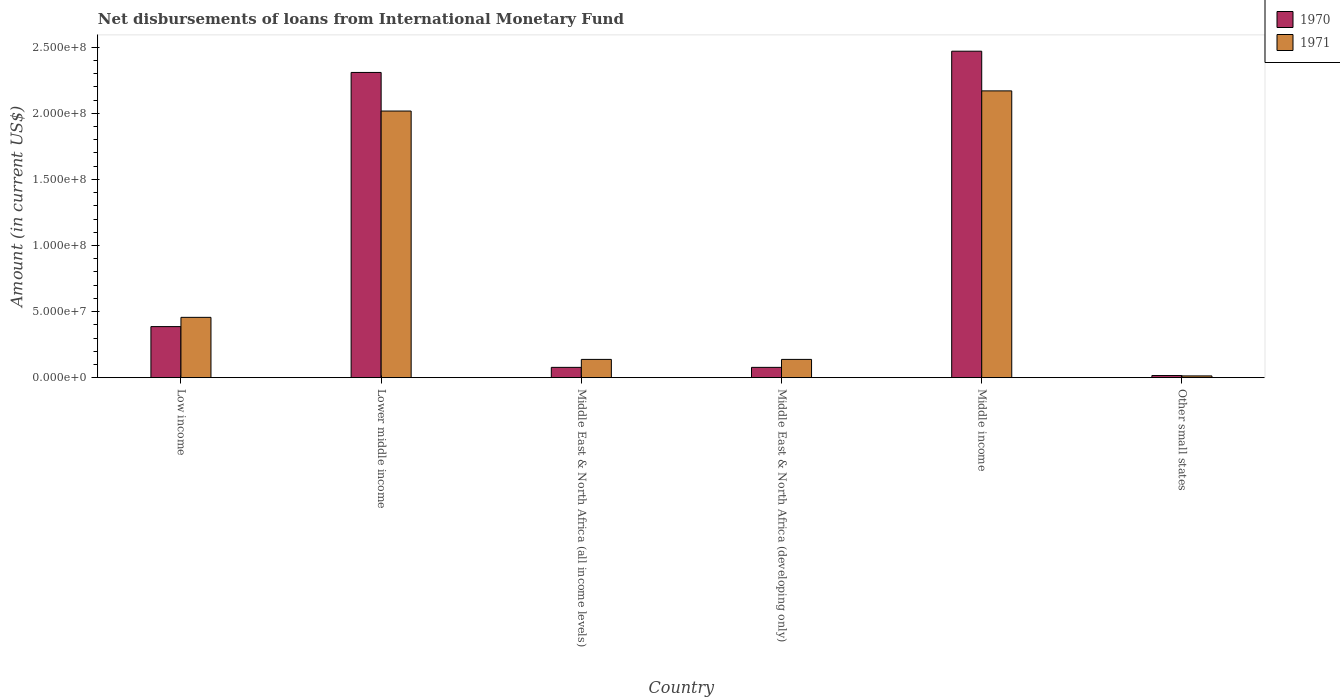How many groups of bars are there?
Make the answer very short. 6. How many bars are there on the 2nd tick from the right?
Your answer should be compact. 2. What is the label of the 2nd group of bars from the left?
Ensure brevity in your answer.  Lower middle income. In how many cases, is the number of bars for a given country not equal to the number of legend labels?
Give a very brief answer. 0. What is the amount of loans disbursed in 1970 in Low income?
Offer a terse response. 3.86e+07. Across all countries, what is the maximum amount of loans disbursed in 1971?
Your answer should be compact. 2.17e+08. Across all countries, what is the minimum amount of loans disbursed in 1970?
Ensure brevity in your answer.  1.61e+06. In which country was the amount of loans disbursed in 1970 minimum?
Your answer should be very brief. Other small states. What is the total amount of loans disbursed in 1971 in the graph?
Ensure brevity in your answer.  4.93e+08. What is the difference between the amount of loans disbursed in 1970 in Middle income and that in Other small states?
Provide a succinct answer. 2.45e+08. What is the difference between the amount of loans disbursed in 1971 in Other small states and the amount of loans disbursed in 1970 in Low income?
Make the answer very short. -3.73e+07. What is the average amount of loans disbursed in 1970 per country?
Make the answer very short. 8.90e+07. What is the difference between the amount of loans disbursed of/in 1971 and amount of loans disbursed of/in 1970 in Middle East & North Africa (all income levels)?
Offer a very short reply. 6.03e+06. In how many countries, is the amount of loans disbursed in 1970 greater than 130000000 US$?
Your answer should be compact. 2. What is the ratio of the amount of loans disbursed in 1970 in Middle income to that in Other small states?
Offer a very short reply. 153.71. Is the amount of loans disbursed in 1971 in Middle income less than that in Other small states?
Make the answer very short. No. What is the difference between the highest and the second highest amount of loans disbursed in 1971?
Offer a terse response. 1.71e+08. What is the difference between the highest and the lowest amount of loans disbursed in 1971?
Provide a short and direct response. 2.16e+08. In how many countries, is the amount of loans disbursed in 1971 greater than the average amount of loans disbursed in 1971 taken over all countries?
Keep it short and to the point. 2. What does the 1st bar from the right in Lower middle income represents?
Your answer should be very brief. 1971. Are all the bars in the graph horizontal?
Your answer should be very brief. No. Are the values on the major ticks of Y-axis written in scientific E-notation?
Make the answer very short. Yes. Does the graph contain grids?
Ensure brevity in your answer.  No. Where does the legend appear in the graph?
Offer a terse response. Top right. How many legend labels are there?
Give a very brief answer. 2. How are the legend labels stacked?
Offer a terse response. Vertical. What is the title of the graph?
Your answer should be compact. Net disbursements of loans from International Monetary Fund. What is the label or title of the X-axis?
Give a very brief answer. Country. What is the label or title of the Y-axis?
Your answer should be compact. Amount (in current US$). What is the Amount (in current US$) in 1970 in Low income?
Make the answer very short. 3.86e+07. What is the Amount (in current US$) of 1971 in Low income?
Provide a short and direct response. 4.56e+07. What is the Amount (in current US$) in 1970 in Lower middle income?
Provide a short and direct response. 2.31e+08. What is the Amount (in current US$) of 1971 in Lower middle income?
Keep it short and to the point. 2.02e+08. What is the Amount (in current US$) in 1970 in Middle East & North Africa (all income levels)?
Your response must be concise. 7.79e+06. What is the Amount (in current US$) in 1971 in Middle East & North Africa (all income levels)?
Offer a terse response. 1.38e+07. What is the Amount (in current US$) of 1970 in Middle East & North Africa (developing only)?
Your answer should be very brief. 7.79e+06. What is the Amount (in current US$) of 1971 in Middle East & North Africa (developing only)?
Ensure brevity in your answer.  1.38e+07. What is the Amount (in current US$) in 1970 in Middle income?
Ensure brevity in your answer.  2.47e+08. What is the Amount (in current US$) of 1971 in Middle income?
Your answer should be compact. 2.17e+08. What is the Amount (in current US$) of 1970 in Other small states?
Provide a short and direct response. 1.61e+06. What is the Amount (in current US$) in 1971 in Other small states?
Your response must be concise. 1.32e+06. Across all countries, what is the maximum Amount (in current US$) in 1970?
Your answer should be compact. 2.47e+08. Across all countries, what is the maximum Amount (in current US$) of 1971?
Your answer should be compact. 2.17e+08. Across all countries, what is the minimum Amount (in current US$) of 1970?
Your response must be concise. 1.61e+06. Across all countries, what is the minimum Amount (in current US$) of 1971?
Keep it short and to the point. 1.32e+06. What is the total Amount (in current US$) in 1970 in the graph?
Your answer should be compact. 5.34e+08. What is the total Amount (in current US$) in 1971 in the graph?
Provide a short and direct response. 4.93e+08. What is the difference between the Amount (in current US$) of 1970 in Low income and that in Lower middle income?
Keep it short and to the point. -1.92e+08. What is the difference between the Amount (in current US$) of 1971 in Low income and that in Lower middle income?
Offer a terse response. -1.56e+08. What is the difference between the Amount (in current US$) in 1970 in Low income and that in Middle East & North Africa (all income levels)?
Offer a terse response. 3.08e+07. What is the difference between the Amount (in current US$) in 1971 in Low income and that in Middle East & North Africa (all income levels)?
Your answer should be very brief. 3.18e+07. What is the difference between the Amount (in current US$) of 1970 in Low income and that in Middle East & North Africa (developing only)?
Make the answer very short. 3.08e+07. What is the difference between the Amount (in current US$) of 1971 in Low income and that in Middle East & North Africa (developing only)?
Keep it short and to the point. 3.18e+07. What is the difference between the Amount (in current US$) in 1970 in Low income and that in Middle income?
Offer a terse response. -2.08e+08. What is the difference between the Amount (in current US$) of 1971 in Low income and that in Middle income?
Ensure brevity in your answer.  -1.71e+08. What is the difference between the Amount (in current US$) in 1970 in Low income and that in Other small states?
Provide a succinct answer. 3.70e+07. What is the difference between the Amount (in current US$) in 1971 in Low income and that in Other small states?
Your answer should be very brief. 4.43e+07. What is the difference between the Amount (in current US$) of 1970 in Lower middle income and that in Middle East & North Africa (all income levels)?
Provide a short and direct response. 2.23e+08. What is the difference between the Amount (in current US$) of 1971 in Lower middle income and that in Middle East & North Africa (all income levels)?
Your answer should be compact. 1.88e+08. What is the difference between the Amount (in current US$) in 1970 in Lower middle income and that in Middle East & North Africa (developing only)?
Make the answer very short. 2.23e+08. What is the difference between the Amount (in current US$) of 1971 in Lower middle income and that in Middle East & North Africa (developing only)?
Keep it short and to the point. 1.88e+08. What is the difference between the Amount (in current US$) in 1970 in Lower middle income and that in Middle income?
Keep it short and to the point. -1.61e+07. What is the difference between the Amount (in current US$) of 1971 in Lower middle income and that in Middle income?
Keep it short and to the point. -1.52e+07. What is the difference between the Amount (in current US$) in 1970 in Lower middle income and that in Other small states?
Give a very brief answer. 2.29e+08. What is the difference between the Amount (in current US$) of 1971 in Lower middle income and that in Other small states?
Offer a very short reply. 2.00e+08. What is the difference between the Amount (in current US$) of 1970 in Middle East & North Africa (all income levels) and that in Middle East & North Africa (developing only)?
Your response must be concise. 0. What is the difference between the Amount (in current US$) of 1970 in Middle East & North Africa (all income levels) and that in Middle income?
Give a very brief answer. -2.39e+08. What is the difference between the Amount (in current US$) in 1971 in Middle East & North Africa (all income levels) and that in Middle income?
Keep it short and to the point. -2.03e+08. What is the difference between the Amount (in current US$) of 1970 in Middle East & North Africa (all income levels) and that in Other small states?
Your answer should be very brief. 6.19e+06. What is the difference between the Amount (in current US$) of 1971 in Middle East & North Africa (all income levels) and that in Other small states?
Your answer should be very brief. 1.25e+07. What is the difference between the Amount (in current US$) in 1970 in Middle East & North Africa (developing only) and that in Middle income?
Keep it short and to the point. -2.39e+08. What is the difference between the Amount (in current US$) in 1971 in Middle East & North Africa (developing only) and that in Middle income?
Make the answer very short. -2.03e+08. What is the difference between the Amount (in current US$) of 1970 in Middle East & North Africa (developing only) and that in Other small states?
Ensure brevity in your answer.  6.19e+06. What is the difference between the Amount (in current US$) of 1971 in Middle East & North Africa (developing only) and that in Other small states?
Your answer should be very brief. 1.25e+07. What is the difference between the Amount (in current US$) in 1970 in Middle income and that in Other small states?
Your answer should be compact. 2.45e+08. What is the difference between the Amount (in current US$) in 1971 in Middle income and that in Other small states?
Make the answer very short. 2.16e+08. What is the difference between the Amount (in current US$) of 1970 in Low income and the Amount (in current US$) of 1971 in Lower middle income?
Ensure brevity in your answer.  -1.63e+08. What is the difference between the Amount (in current US$) of 1970 in Low income and the Amount (in current US$) of 1971 in Middle East & North Africa (all income levels)?
Keep it short and to the point. 2.48e+07. What is the difference between the Amount (in current US$) of 1970 in Low income and the Amount (in current US$) of 1971 in Middle East & North Africa (developing only)?
Offer a terse response. 2.48e+07. What is the difference between the Amount (in current US$) in 1970 in Low income and the Amount (in current US$) in 1971 in Middle income?
Offer a very short reply. -1.78e+08. What is the difference between the Amount (in current US$) in 1970 in Low income and the Amount (in current US$) in 1971 in Other small states?
Offer a very short reply. 3.73e+07. What is the difference between the Amount (in current US$) of 1970 in Lower middle income and the Amount (in current US$) of 1971 in Middle East & North Africa (all income levels)?
Make the answer very short. 2.17e+08. What is the difference between the Amount (in current US$) of 1970 in Lower middle income and the Amount (in current US$) of 1971 in Middle East & North Africa (developing only)?
Keep it short and to the point. 2.17e+08. What is the difference between the Amount (in current US$) of 1970 in Lower middle income and the Amount (in current US$) of 1971 in Middle income?
Offer a terse response. 1.40e+07. What is the difference between the Amount (in current US$) of 1970 in Lower middle income and the Amount (in current US$) of 1971 in Other small states?
Give a very brief answer. 2.30e+08. What is the difference between the Amount (in current US$) of 1970 in Middle East & North Africa (all income levels) and the Amount (in current US$) of 1971 in Middle East & North Africa (developing only)?
Provide a short and direct response. -6.03e+06. What is the difference between the Amount (in current US$) of 1970 in Middle East & North Africa (all income levels) and the Amount (in current US$) of 1971 in Middle income?
Your answer should be very brief. -2.09e+08. What is the difference between the Amount (in current US$) in 1970 in Middle East & North Africa (all income levels) and the Amount (in current US$) in 1971 in Other small states?
Your answer should be very brief. 6.47e+06. What is the difference between the Amount (in current US$) of 1970 in Middle East & North Africa (developing only) and the Amount (in current US$) of 1971 in Middle income?
Make the answer very short. -2.09e+08. What is the difference between the Amount (in current US$) in 1970 in Middle East & North Africa (developing only) and the Amount (in current US$) in 1971 in Other small states?
Provide a succinct answer. 6.47e+06. What is the difference between the Amount (in current US$) of 1970 in Middle income and the Amount (in current US$) of 1971 in Other small states?
Offer a very short reply. 2.46e+08. What is the average Amount (in current US$) of 1970 per country?
Give a very brief answer. 8.90e+07. What is the average Amount (in current US$) in 1971 per country?
Make the answer very short. 8.22e+07. What is the difference between the Amount (in current US$) in 1970 and Amount (in current US$) in 1971 in Low income?
Your answer should be compact. -6.99e+06. What is the difference between the Amount (in current US$) in 1970 and Amount (in current US$) in 1971 in Lower middle income?
Your answer should be compact. 2.92e+07. What is the difference between the Amount (in current US$) in 1970 and Amount (in current US$) in 1971 in Middle East & North Africa (all income levels)?
Your answer should be compact. -6.03e+06. What is the difference between the Amount (in current US$) in 1970 and Amount (in current US$) in 1971 in Middle East & North Africa (developing only)?
Make the answer very short. -6.03e+06. What is the difference between the Amount (in current US$) of 1970 and Amount (in current US$) of 1971 in Middle income?
Offer a terse response. 3.00e+07. What is the difference between the Amount (in current US$) in 1970 and Amount (in current US$) in 1971 in Other small states?
Your answer should be very brief. 2.85e+05. What is the ratio of the Amount (in current US$) of 1970 in Low income to that in Lower middle income?
Your answer should be compact. 0.17. What is the ratio of the Amount (in current US$) in 1971 in Low income to that in Lower middle income?
Your answer should be very brief. 0.23. What is the ratio of the Amount (in current US$) in 1970 in Low income to that in Middle East & North Africa (all income levels)?
Offer a very short reply. 4.96. What is the ratio of the Amount (in current US$) in 1971 in Low income to that in Middle East & North Africa (all income levels)?
Provide a short and direct response. 3.3. What is the ratio of the Amount (in current US$) in 1970 in Low income to that in Middle East & North Africa (developing only)?
Make the answer very short. 4.96. What is the ratio of the Amount (in current US$) of 1971 in Low income to that in Middle East & North Africa (developing only)?
Offer a very short reply. 3.3. What is the ratio of the Amount (in current US$) in 1970 in Low income to that in Middle income?
Provide a short and direct response. 0.16. What is the ratio of the Amount (in current US$) in 1971 in Low income to that in Middle income?
Provide a short and direct response. 0.21. What is the ratio of the Amount (in current US$) of 1970 in Low income to that in Other small states?
Make the answer very short. 24.04. What is the ratio of the Amount (in current US$) of 1971 in Low income to that in Other small states?
Keep it short and to the point. 34.52. What is the ratio of the Amount (in current US$) of 1970 in Lower middle income to that in Middle East & North Africa (all income levels)?
Your answer should be compact. 29.63. What is the ratio of the Amount (in current US$) of 1971 in Lower middle income to that in Middle East & North Africa (all income levels)?
Ensure brevity in your answer.  14.6. What is the ratio of the Amount (in current US$) in 1970 in Lower middle income to that in Middle East & North Africa (developing only)?
Your answer should be very brief. 29.63. What is the ratio of the Amount (in current US$) in 1971 in Lower middle income to that in Middle East & North Africa (developing only)?
Make the answer very short. 14.6. What is the ratio of the Amount (in current US$) of 1970 in Lower middle income to that in Middle income?
Your response must be concise. 0.93. What is the ratio of the Amount (in current US$) in 1971 in Lower middle income to that in Middle income?
Give a very brief answer. 0.93. What is the ratio of the Amount (in current US$) of 1970 in Lower middle income to that in Other small states?
Offer a terse response. 143.71. What is the ratio of the Amount (in current US$) of 1971 in Lower middle income to that in Other small states?
Give a very brief answer. 152.6. What is the ratio of the Amount (in current US$) in 1971 in Middle East & North Africa (all income levels) to that in Middle East & North Africa (developing only)?
Offer a terse response. 1. What is the ratio of the Amount (in current US$) in 1970 in Middle East & North Africa (all income levels) to that in Middle income?
Your answer should be very brief. 0.03. What is the ratio of the Amount (in current US$) in 1971 in Middle East & North Africa (all income levels) to that in Middle income?
Provide a short and direct response. 0.06. What is the ratio of the Amount (in current US$) in 1970 in Middle East & North Africa (all income levels) to that in Other small states?
Your answer should be compact. 4.85. What is the ratio of the Amount (in current US$) of 1971 in Middle East & North Africa (all income levels) to that in Other small states?
Your response must be concise. 10.45. What is the ratio of the Amount (in current US$) in 1970 in Middle East & North Africa (developing only) to that in Middle income?
Ensure brevity in your answer.  0.03. What is the ratio of the Amount (in current US$) of 1971 in Middle East & North Africa (developing only) to that in Middle income?
Your answer should be very brief. 0.06. What is the ratio of the Amount (in current US$) of 1970 in Middle East & North Africa (developing only) to that in Other small states?
Keep it short and to the point. 4.85. What is the ratio of the Amount (in current US$) of 1971 in Middle East & North Africa (developing only) to that in Other small states?
Your response must be concise. 10.45. What is the ratio of the Amount (in current US$) in 1970 in Middle income to that in Other small states?
Make the answer very short. 153.71. What is the ratio of the Amount (in current US$) of 1971 in Middle income to that in Other small states?
Provide a succinct answer. 164.14. What is the difference between the highest and the second highest Amount (in current US$) of 1970?
Offer a very short reply. 1.61e+07. What is the difference between the highest and the second highest Amount (in current US$) in 1971?
Your answer should be compact. 1.52e+07. What is the difference between the highest and the lowest Amount (in current US$) of 1970?
Ensure brevity in your answer.  2.45e+08. What is the difference between the highest and the lowest Amount (in current US$) in 1971?
Give a very brief answer. 2.16e+08. 